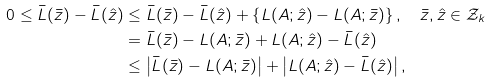<formula> <loc_0><loc_0><loc_500><loc_500>0 \leq \bar { L } ( \bar { z } ) - \bar { L } ( \hat { z } ) & \leq \bar { L } ( \bar { z } ) - \bar { L } ( \hat { z } ) + \left \{ L ( A ; \hat { z } ) - L ( A ; \bar { z } ) \right \} , \quad \bar { z } , \hat { z } \in \mathcal { Z } _ { k } \\ & = \bar { L } ( \bar { z } ) - L ( A ; \bar { z } ) + L ( A ; \hat { z } ) - \bar { L } ( \hat { z } ) \\ & \leq \left | \bar { L } ( \bar { z } ) - L ( A ; \bar { z } ) \right | + \left | L ( A ; \hat { z } ) - \bar { L } ( \hat { z } ) \right | ,</formula> 